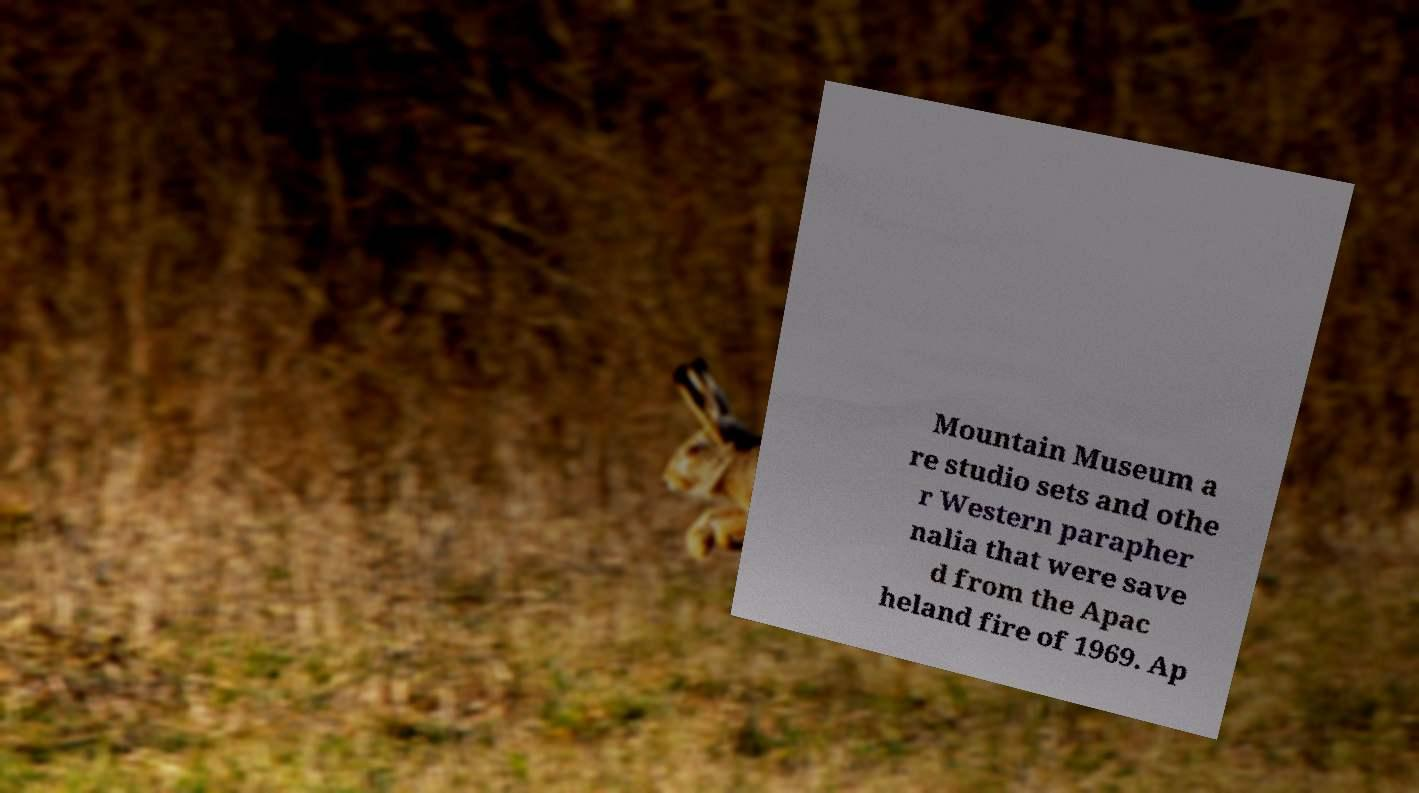Please read and relay the text visible in this image. What does it say? Mountain Museum a re studio sets and othe r Western parapher nalia that were save d from the Apac heland fire of 1969. Ap 